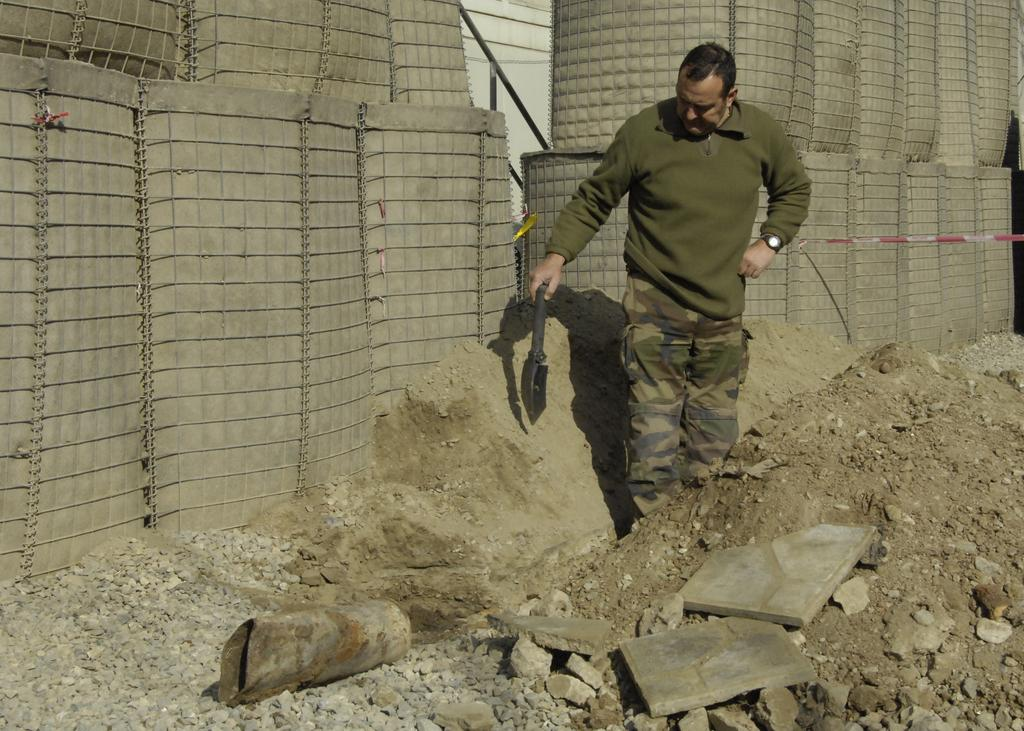What is the main subject of the image? There is a man in the image. What is the man holding in his hand? The man is holding an instrument in his hand. What type of objects can be seen on the ground in the image? There are stones visible in the image. What can be seen in the background of the image? There appears to be a fence in the background of the image. Can you tell me where the zebra is standing in the image? There is no zebra present in the image. What type of jewelry is the man wearing in the image? The provided facts do not mention any jewelry, such as a locket, being worn by the man in the image. 